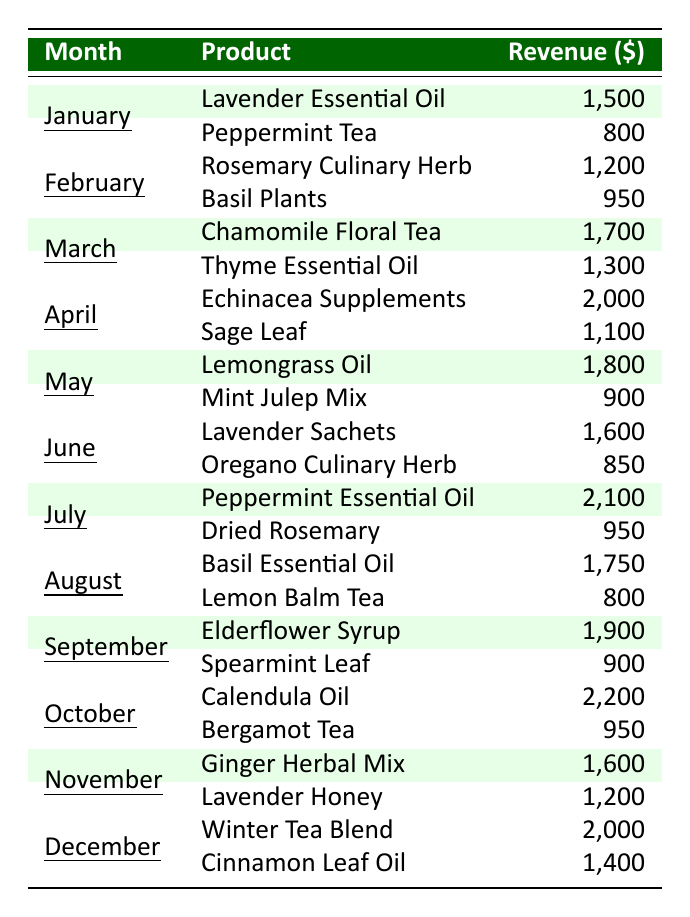What was the total revenue from botanical products in July? In July, the table shows two products: Peppermint Essential Oil with revenue of 2,100 and Dried Rosemary with revenue of 950. Adding these together gives 2,100 + 950 = 3,050.
Answer: 3,050 Which month had the highest sales revenue? The month of October shows the highest revenue with Calendula Oil at 2,200 and Bergamot Tea at 950, totaling 3,150. This is greater than any other month's total revenue.
Answer: October What product generated the most revenue in December? In December, the two products listed are Winter Tea Blend with 2,000 and Cinnamon Leaf Oil with 1,400. Since 2,000 is greater than 1,400, Winter Tea Blend generated the most revenue.
Answer: Winter Tea Blend Which month had higher revenue, March or April? In March, the total revenue is 1,700 (Chamomile Floral Tea) + 1,300 (Thyme Essential Oil) = 3,000. In April, it is 2,000 (Echinacea Supplements) + 1,100 (Sage Leaf) = 3,100. Since 3,100 > 3,000, April had higher revenue.
Answer: April Was the revenue from Lavender Essential Oil greater than that from Sage Leaf in any month? The revenue from Lavender Essential Oil in January is 1,500. The revenue from Sage Leaf in April is 1,100. Since 1,500 is greater than 1,100, yes, it was greater in January.
Answer: Yes What is the average monthly revenue for the year? Adding all revenues gives a total of 21,500 over 12 months. Dividing 21,500 by 12 results in an average revenue of 1,791.67.
Answer: 1,791.67 How much did Echinacea Supplements earn compared to Elderflower Syrup? Echinacea Supplements earned 2,000 in April, while Elderflower Syrup earned 1,900 in September. Calculating the difference gives 2,000 - 1,900 = 100.
Answer: 100 Which botanical product had the lowest revenue in November? In November, Ginger Herbal Mix earned 1,600 and Lavender Honey earned 1,200. Since 1,200 is less than 1,600, Lavender Honey had the lowest revenue.
Answer: Lavender Honey What was the cumulative revenue from botanical sales from January to June? Summing the monthly revenues from January (2,300), February (2,150), March (3,000), April (3,100), May (2,700), and June (2,450) gives a total of 15,650.
Answer: 15,650 Did the total revenue in August exceed that of February? In August, the total revenue is Basil Essential Oil at 1,750 and Lemon Balm Tea at 800, totaling 2,550. For February, it's 1,200 (Rosemary Culinary Herb) + 950 (Basil Plants) = 2,150. Since 2,550 > 2,150, it did exceed February's total.
Answer: Yes What is the difference in revenue between the highest and lowest earning products in 2023? The highest earning product is Calendula Oil at 2,200 and the lowest is Peppermint Tea at 800. The difference is 2,200 - 800 = 1,400.
Answer: 1,400 